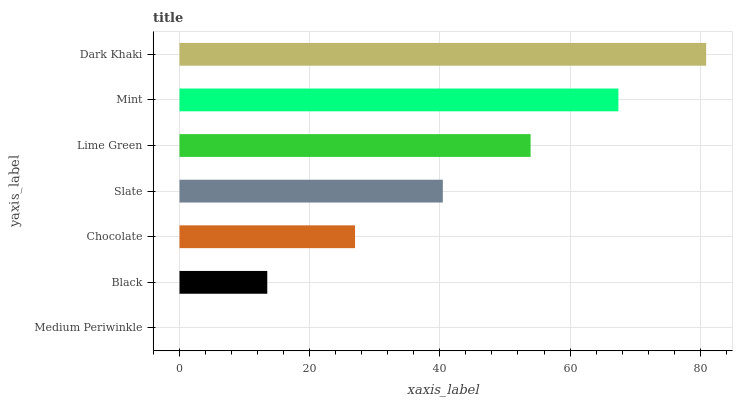Is Medium Periwinkle the minimum?
Answer yes or no. Yes. Is Dark Khaki the maximum?
Answer yes or no. Yes. Is Black the minimum?
Answer yes or no. No. Is Black the maximum?
Answer yes or no. No. Is Black greater than Medium Periwinkle?
Answer yes or no. Yes. Is Medium Periwinkle less than Black?
Answer yes or no. Yes. Is Medium Periwinkle greater than Black?
Answer yes or no. No. Is Black less than Medium Periwinkle?
Answer yes or no. No. Is Slate the high median?
Answer yes or no. Yes. Is Slate the low median?
Answer yes or no. Yes. Is Dark Khaki the high median?
Answer yes or no. No. Is Dark Khaki the low median?
Answer yes or no. No. 